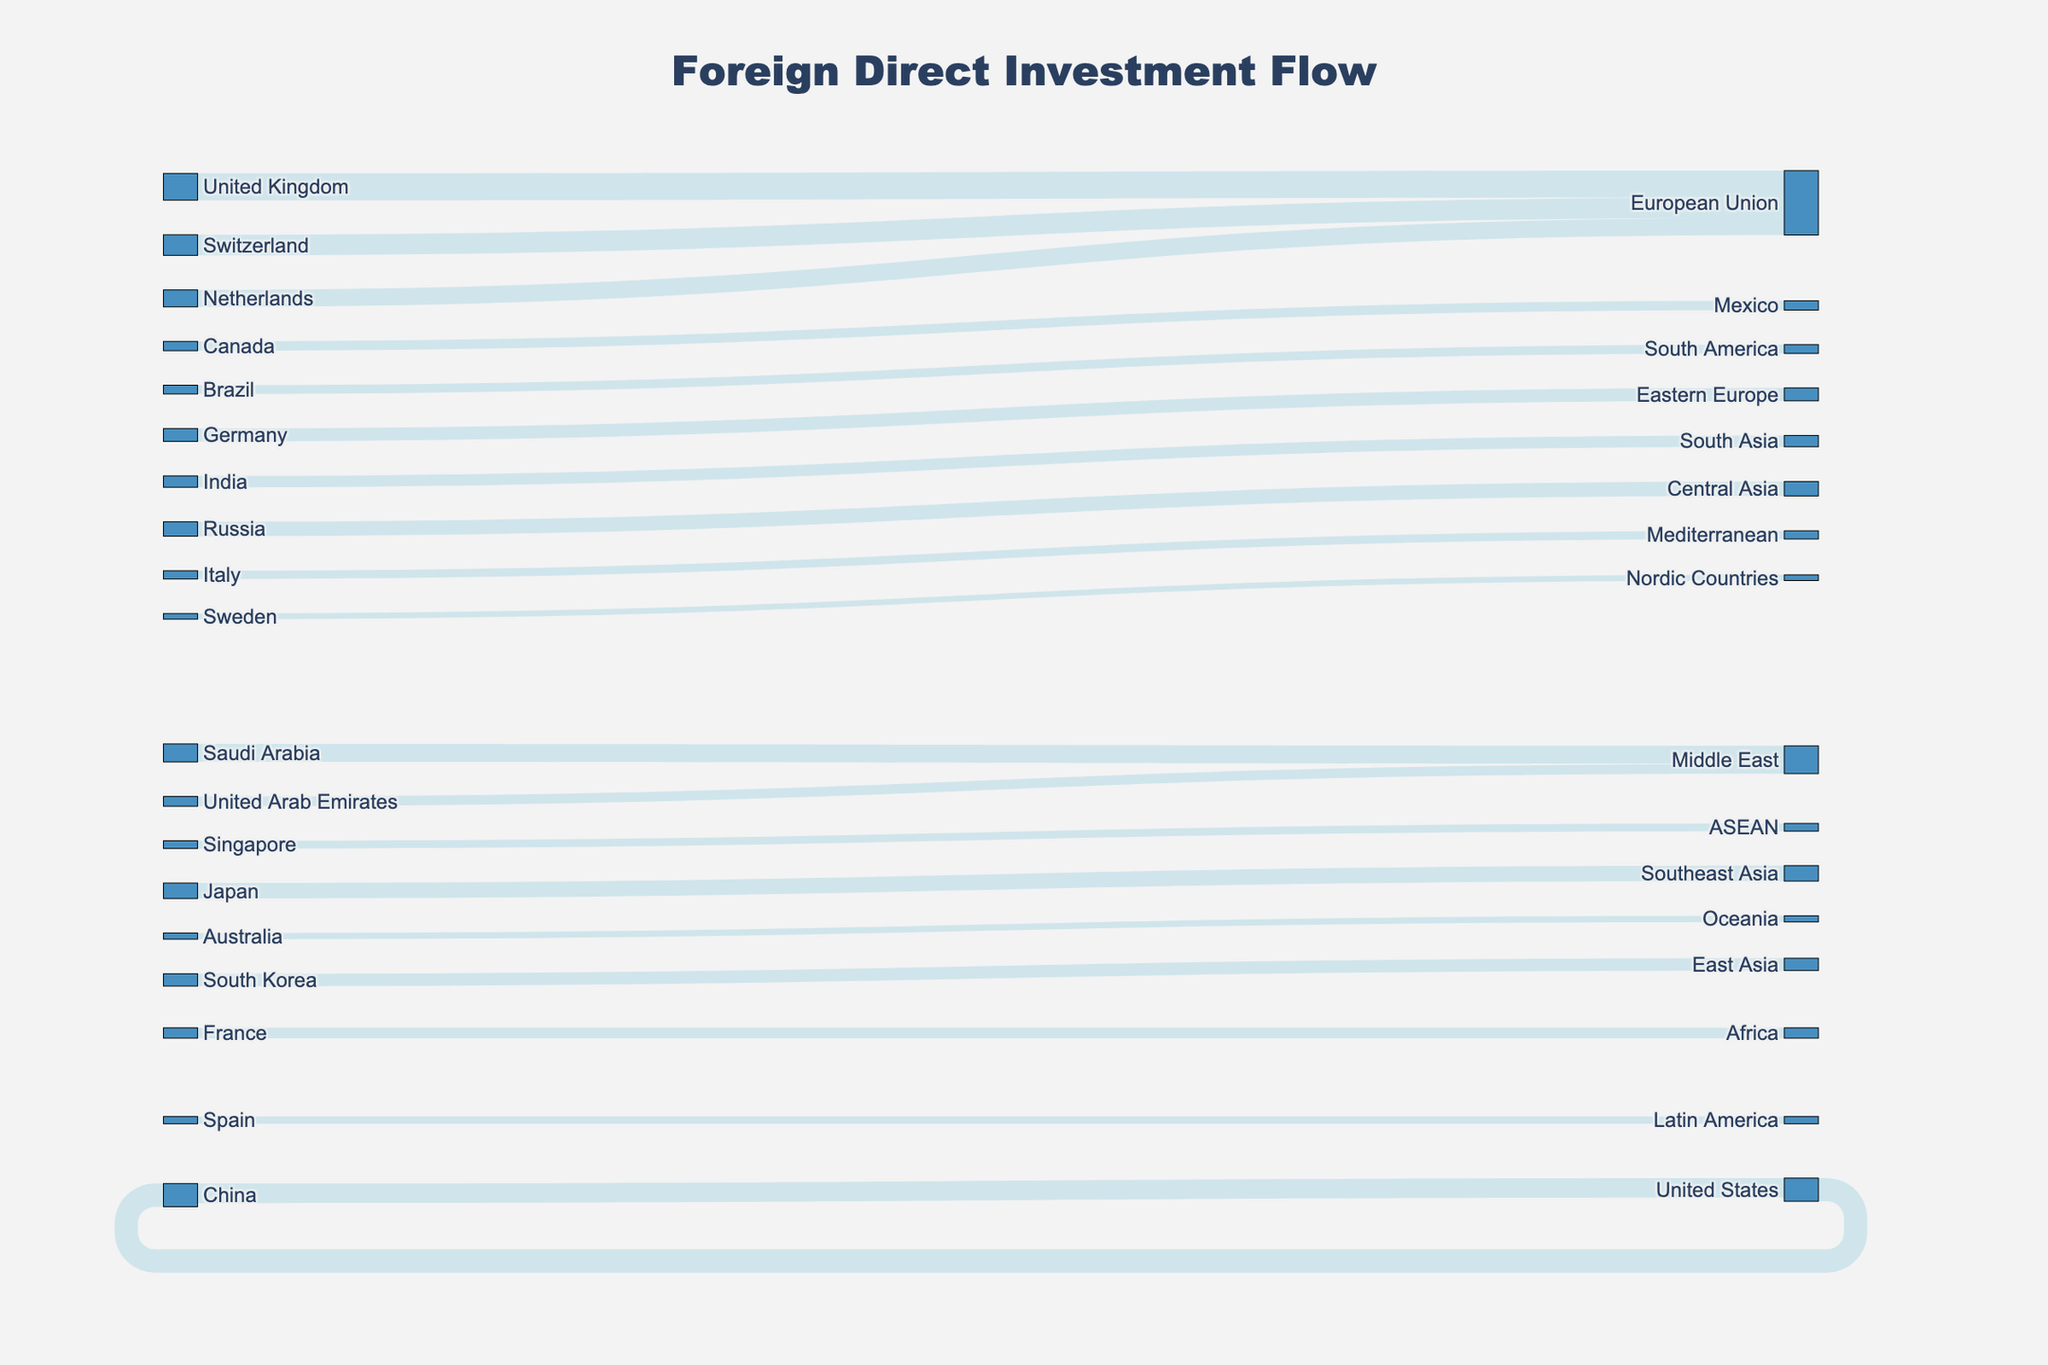what is the total number of countries involved in the sankey diagram? To count the total number of countries involved, both as sources and targets, we must list all unique names in both columns. By compiling the list and removing duplicates, we get 22 unique countries.
Answer: 22 Which country is the largest source of foreign direct investment to China? By looking at the Sankey diagram, we can see various links going to China. The largest source according to the diagram is the United States contributing 45 units of investment.
Answer: United States What is the sum of foreign direct investments flowing into the European Union? To find the total investment received by the European Union, we add investments from all source countries: United Kingdom (52), Switzerland (40), and Netherlands (33). Adding these values gives us 52+40+33 = 125 units.
Answer: 125 Which region has the highest cumulative incoming foreign direct investment and what is its value? By looking at the diagram, we identify regions and sum their incoming values. We find that the European Union has the highest cumulative value with inputs of 52 (UK) + 40 (Switzerland) + 33 (Netherlands) = 125 units.
Answer: European Union with 125 units How does the investment from Saudi Arabia into the Middle East compare to the investment from United Arab Emirates into the same region? According to the diagram, Saudi Arabia invests 35 units in the Middle East while the United Arab Emirates invests 19 units. Saudi Arabia's investment is 35-19 = 16 units more than the UAE's.
Answer: Saudi Arabia invests 16 units more What is the difference between the largest and smallest foreign direct investment values in the diagram? The largest value is 52 units (United Kingdom to European Union) and the smallest is 11 units (Sweden to Nordic Countries). Therefore, the difference is 52 - 11 = 41 units.
Answer: 41 units Which specific regions receive investment from more than two sources according to the diagram? From the diagram, the European Union receives investments from the United Kingdom, Switzerland, and Netherlands. No other target receives investment from more than two sources.
Answer: European Union What is the average amount of foreign direct investment originating from China? China has two outgoing investments: 45 units to the United States and 38 units to another target. Adding these gives us 45 + 38 = 83, and with two outflows, the average is 83 / 2 = 41.5 units.
Answer: 41.5 units Which country invested the highest amount of foreign direct investment into another single country/region in the diagram? From the diagram, the United Kingdom invests the highest single amount which is 52 units into the European Union.
Answer: United Kingdom If we group African and Middle Eastern countries together, what is the total foreign direct investment flowing into this grouping? The African countries receive 20 units from France and the Middle East receives 35 units from Saudi Arabia and 19 units from the UAE, summing to 20 + 35 + 19 = 74 units.
Answer: 74 units 